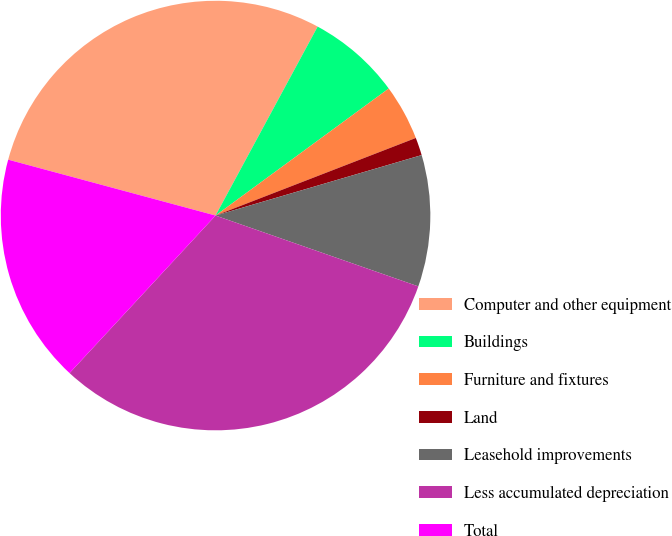Convert chart to OTSL. <chart><loc_0><loc_0><loc_500><loc_500><pie_chart><fcel>Computer and other equipment<fcel>Buildings<fcel>Furniture and fixtures<fcel>Land<fcel>Leasehold improvements<fcel>Less accumulated depreciation<fcel>Total<nl><fcel>28.69%<fcel>7.04%<fcel>4.19%<fcel>1.34%<fcel>9.89%<fcel>31.54%<fcel>17.29%<nl></chart> 